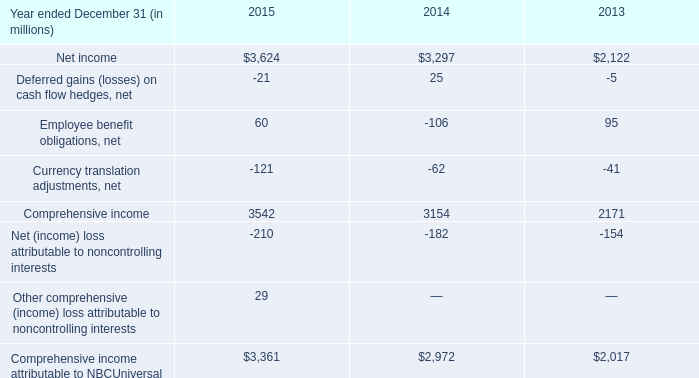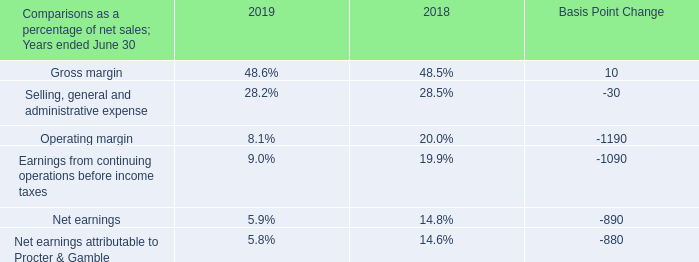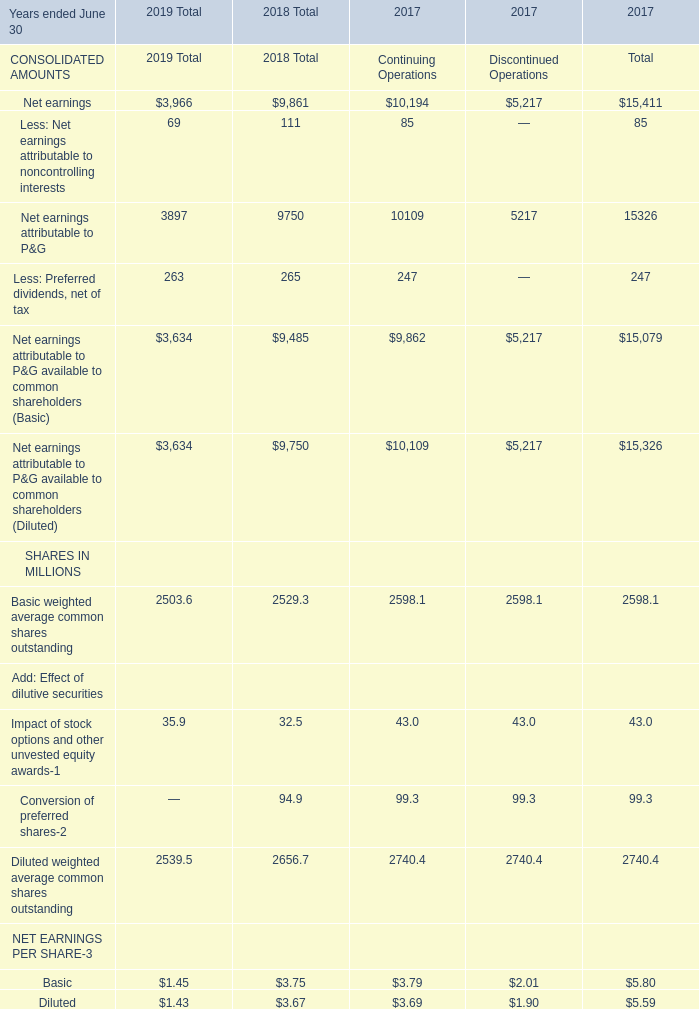In what year is Net earnings greater than 1? 
Answer: 201920182017. 